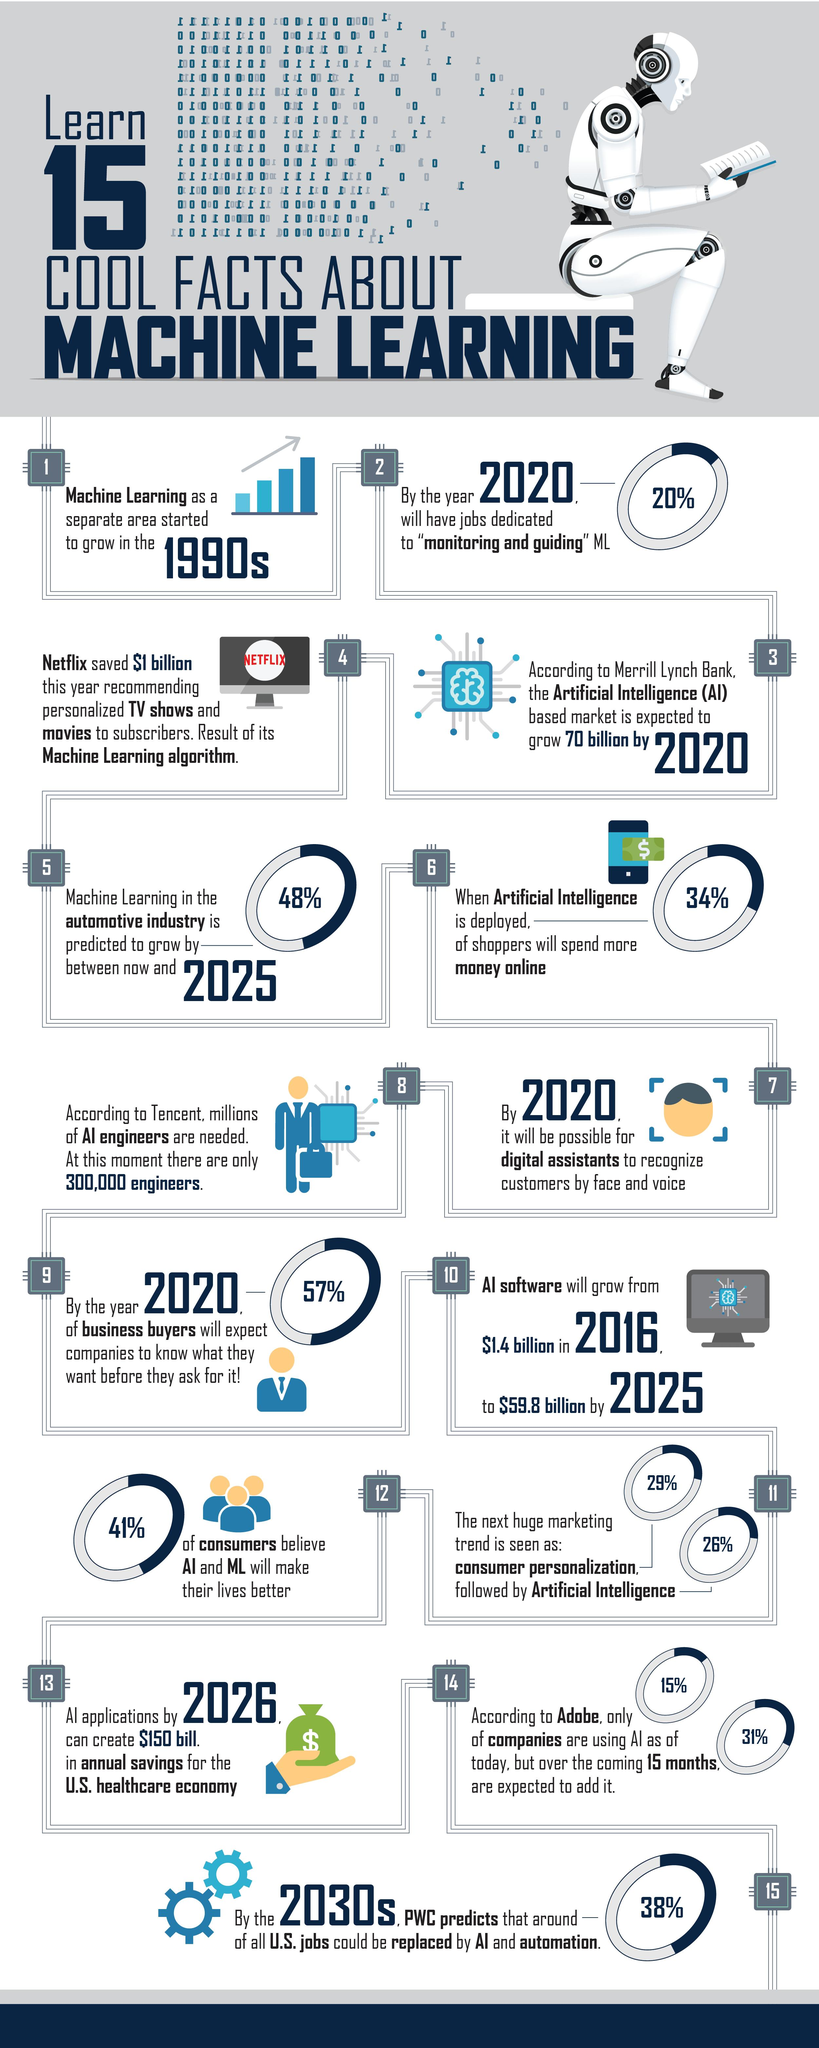Identify some key points in this picture. When artificial intelligence (AI) is deployed for online shopping, a higher percentage of money is spent compared to traditional methods. Specifically, 34% more money is spent when AI is used for online shopping. A significant percentage of consumers, 59%, do not believe that AI and ML will improve their lives. According to estimates, 20% of job openings in the field of machine learning (ML) in 2020 are expected to be in the areas of monitoring and guiding ML. The prediction for the percentage growth of machine learning in the automotive industry by 2025 is 48%. 